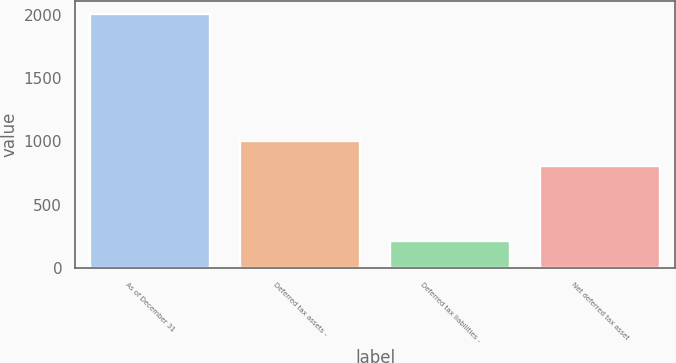Convert chart to OTSL. <chart><loc_0><loc_0><loc_500><loc_500><bar_chart><fcel>As of December 31<fcel>Deferred tax assets -<fcel>Deferred tax liabilities -<fcel>Net deferred tax asset<nl><fcel>2009<fcel>1007.3<fcel>215.3<fcel>808<nl></chart> 